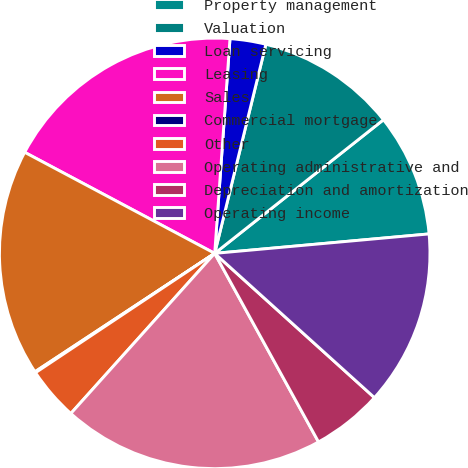Convert chart. <chart><loc_0><loc_0><loc_500><loc_500><pie_chart><fcel>Property management<fcel>Valuation<fcel>Loan servicing<fcel>Leasing<fcel>Sales<fcel>Commercial mortgage<fcel>Other<fcel>Operating administrative and<fcel>Depreciation and amortization<fcel>Operating income<nl><fcel>9.22%<fcel>10.52%<fcel>2.69%<fcel>18.35%<fcel>17.05%<fcel>0.08%<fcel>4.0%<fcel>19.66%<fcel>5.3%<fcel>13.13%<nl></chart> 